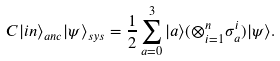<formula> <loc_0><loc_0><loc_500><loc_500>C | i n \rangle _ { a n c } | \psi \rangle _ { s y s } = \frac { 1 } { 2 } \sum _ { a = 0 } ^ { 3 } | a \rangle ( \otimes _ { i = 1 } ^ { n } \sigma _ { a } ^ { i } ) | \psi \rangle .</formula> 